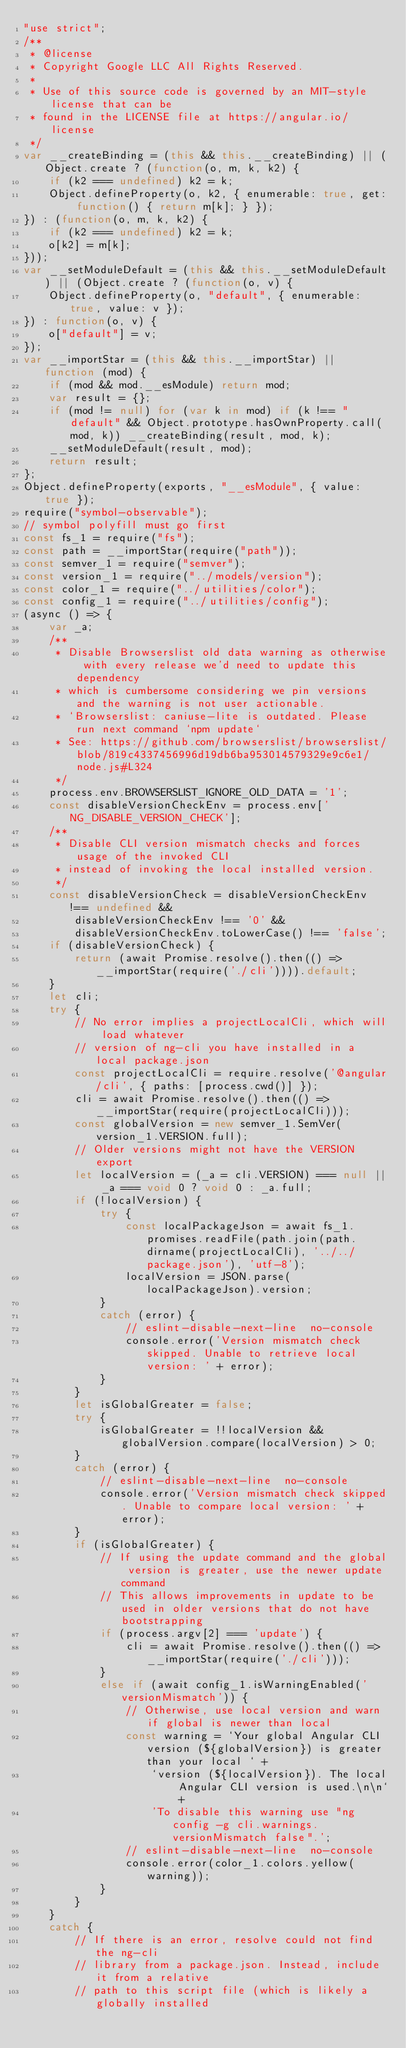<code> <loc_0><loc_0><loc_500><loc_500><_JavaScript_>"use strict";
/**
 * @license
 * Copyright Google LLC All Rights Reserved.
 *
 * Use of this source code is governed by an MIT-style license that can be
 * found in the LICENSE file at https://angular.io/license
 */
var __createBinding = (this && this.__createBinding) || (Object.create ? (function(o, m, k, k2) {
    if (k2 === undefined) k2 = k;
    Object.defineProperty(o, k2, { enumerable: true, get: function() { return m[k]; } });
}) : (function(o, m, k, k2) {
    if (k2 === undefined) k2 = k;
    o[k2] = m[k];
}));
var __setModuleDefault = (this && this.__setModuleDefault) || (Object.create ? (function(o, v) {
    Object.defineProperty(o, "default", { enumerable: true, value: v });
}) : function(o, v) {
    o["default"] = v;
});
var __importStar = (this && this.__importStar) || function (mod) {
    if (mod && mod.__esModule) return mod;
    var result = {};
    if (mod != null) for (var k in mod) if (k !== "default" && Object.prototype.hasOwnProperty.call(mod, k)) __createBinding(result, mod, k);
    __setModuleDefault(result, mod);
    return result;
};
Object.defineProperty(exports, "__esModule", { value: true });
require("symbol-observable");
// symbol polyfill must go first
const fs_1 = require("fs");
const path = __importStar(require("path"));
const semver_1 = require("semver");
const version_1 = require("../models/version");
const color_1 = require("../utilities/color");
const config_1 = require("../utilities/config");
(async () => {
    var _a;
    /**
     * Disable Browserslist old data warning as otherwise with every release we'd need to update this dependency
     * which is cumbersome considering we pin versions and the warning is not user actionable.
     * `Browserslist: caniuse-lite is outdated. Please run next command `npm update`
     * See: https://github.com/browserslist/browserslist/blob/819c4337456996d19db6ba953014579329e9c6e1/node.js#L324
     */
    process.env.BROWSERSLIST_IGNORE_OLD_DATA = '1';
    const disableVersionCheckEnv = process.env['NG_DISABLE_VERSION_CHECK'];
    /**
     * Disable CLI version mismatch checks and forces usage of the invoked CLI
     * instead of invoking the local installed version.
     */
    const disableVersionCheck = disableVersionCheckEnv !== undefined &&
        disableVersionCheckEnv !== '0' &&
        disableVersionCheckEnv.toLowerCase() !== 'false';
    if (disableVersionCheck) {
        return (await Promise.resolve().then(() => __importStar(require('./cli')))).default;
    }
    let cli;
    try {
        // No error implies a projectLocalCli, which will load whatever
        // version of ng-cli you have installed in a local package.json
        const projectLocalCli = require.resolve('@angular/cli', { paths: [process.cwd()] });
        cli = await Promise.resolve().then(() => __importStar(require(projectLocalCli)));
        const globalVersion = new semver_1.SemVer(version_1.VERSION.full);
        // Older versions might not have the VERSION export
        let localVersion = (_a = cli.VERSION) === null || _a === void 0 ? void 0 : _a.full;
        if (!localVersion) {
            try {
                const localPackageJson = await fs_1.promises.readFile(path.join(path.dirname(projectLocalCli), '../../package.json'), 'utf-8');
                localVersion = JSON.parse(localPackageJson).version;
            }
            catch (error) {
                // eslint-disable-next-line  no-console
                console.error('Version mismatch check skipped. Unable to retrieve local version: ' + error);
            }
        }
        let isGlobalGreater = false;
        try {
            isGlobalGreater = !!localVersion && globalVersion.compare(localVersion) > 0;
        }
        catch (error) {
            // eslint-disable-next-line  no-console
            console.error('Version mismatch check skipped. Unable to compare local version: ' + error);
        }
        if (isGlobalGreater) {
            // If using the update command and the global version is greater, use the newer update command
            // This allows improvements in update to be used in older versions that do not have bootstrapping
            if (process.argv[2] === 'update') {
                cli = await Promise.resolve().then(() => __importStar(require('./cli')));
            }
            else if (await config_1.isWarningEnabled('versionMismatch')) {
                // Otherwise, use local version and warn if global is newer than local
                const warning = `Your global Angular CLI version (${globalVersion}) is greater than your local ` +
                    `version (${localVersion}). The local Angular CLI version is used.\n\n` +
                    'To disable this warning use "ng config -g cli.warnings.versionMismatch false".';
                // eslint-disable-next-line  no-console
                console.error(color_1.colors.yellow(warning));
            }
        }
    }
    catch {
        // If there is an error, resolve could not find the ng-cli
        // library from a package.json. Instead, include it from a relative
        // path to this script file (which is likely a globally installed</code> 